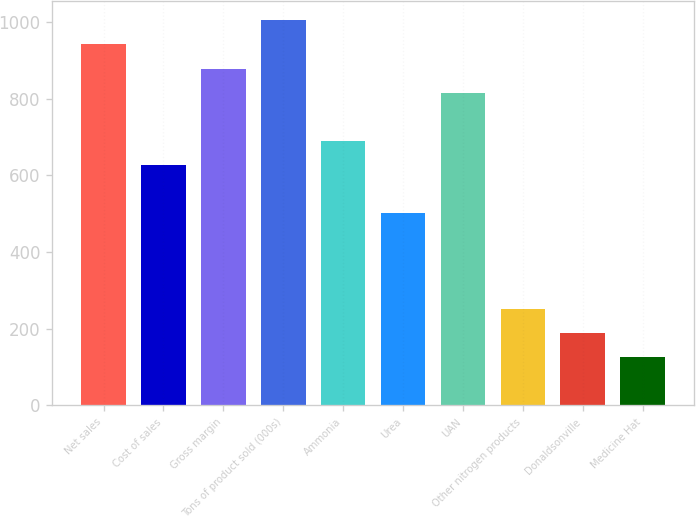Convert chart to OTSL. <chart><loc_0><loc_0><loc_500><loc_500><bar_chart><fcel>Net sales<fcel>Cost of sales<fcel>Gross margin<fcel>Tons of product sold (000s)<fcel>Ammonia<fcel>Urea<fcel>UAN<fcel>Other nitrogen products<fcel>Donaldsonville<fcel>Medicine Hat<nl><fcel>941.89<fcel>627.99<fcel>879.11<fcel>1004.67<fcel>690.77<fcel>502.43<fcel>816.33<fcel>251.31<fcel>188.53<fcel>125.75<nl></chart> 